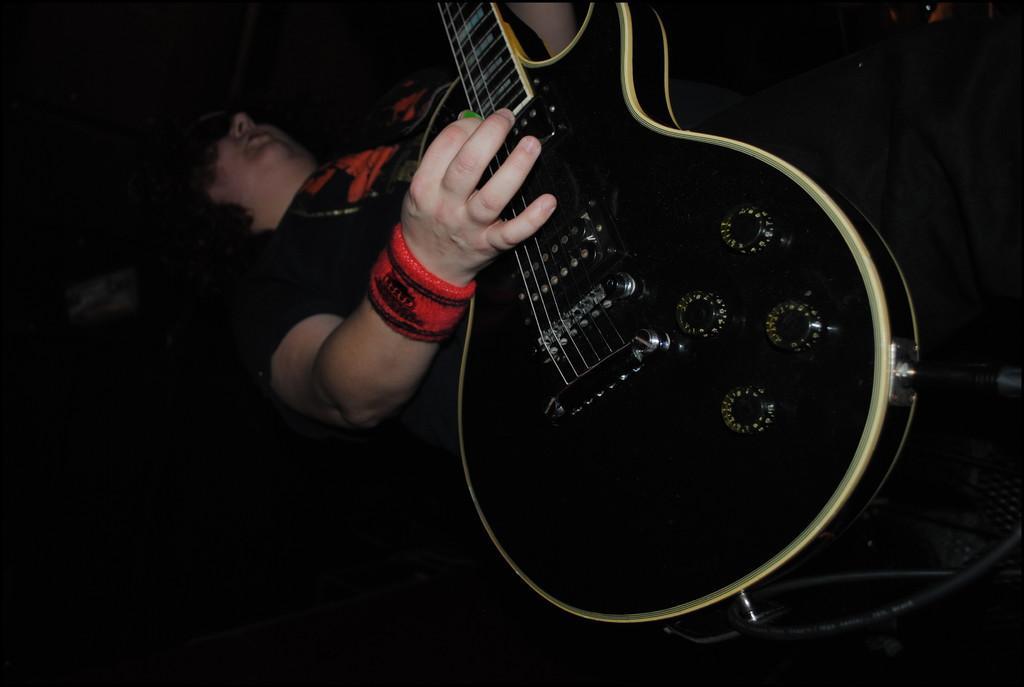In one or two sentences, can you explain what this image depicts? This person wore black t-shirt and playing this black guitar. 